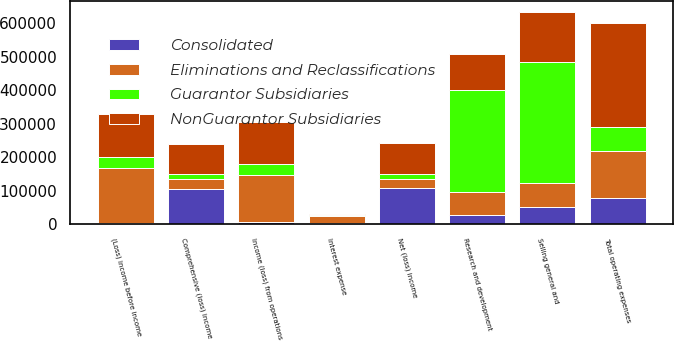Convert chart to OTSL. <chart><loc_0><loc_0><loc_500><loc_500><stacked_bar_chart><ecel><fcel>Research and development<fcel>Selling general and<fcel>Total operating expenses<fcel>Income (loss) from operations<fcel>Interest expense<fcel>(Loss) income before income<fcel>Net (loss) income<fcel>Comprehensive (loss) income<nl><fcel>Eliminations and Reclassifications<fcel>67158<fcel>72358<fcel>139516<fcel>139516<fcel>21895<fcel>161411<fcel>28845<fcel>31854<nl><fcel>NonGuarantor Subsidiaries<fcel>106560<fcel>151814<fcel>309302<fcel>124424<fcel>2419<fcel>130122<fcel>93990<fcel>89738<nl><fcel>Guarantor Subsidiaries<fcel>304219<fcel>360593<fcel>72358<fcel>34189<fcel>3029<fcel>33865<fcel>13619<fcel>14862<nl><fcel>Consolidated<fcel>29174<fcel>50666<fcel>78492<fcel>7129<fcel>4027<fcel>5438<fcel>107609<fcel>104600<nl></chart> 